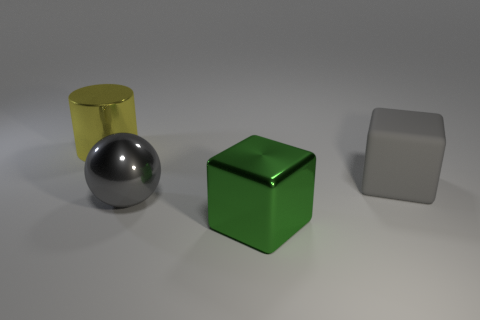Is there anything else that has the same shape as the big gray shiny thing?
Provide a short and direct response. No. The thing behind the big gray rubber block has what shape?
Your response must be concise. Cylinder. There is another object that is the same shape as the large green object; what material is it?
Your answer should be compact. Rubber. There is a thing to the right of the green block; does it have the same size as the gray metal sphere?
Your answer should be compact. Yes. What number of gray metallic spheres are behind the rubber thing?
Your answer should be very brief. 0. Are there fewer metallic cubes that are right of the large gray metal sphere than yellow metal cylinders that are behind the matte thing?
Your answer should be very brief. No. How many small brown blocks are there?
Make the answer very short. 0. There is a block behind the large green metallic cube; what color is it?
Your answer should be very brief. Gray. How big is the green thing?
Your response must be concise. Large. Do the big ball and the block in front of the large gray cube have the same color?
Ensure brevity in your answer.  No. 